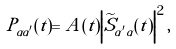Convert formula to latex. <formula><loc_0><loc_0><loc_500><loc_500>P _ { \alpha \alpha ^ { \prime } } ( t ) = A ( t ) \left | \widetilde { S } _ { \alpha ^ { \prime } \alpha } ( t ) \right | ^ { 2 } ,</formula> 